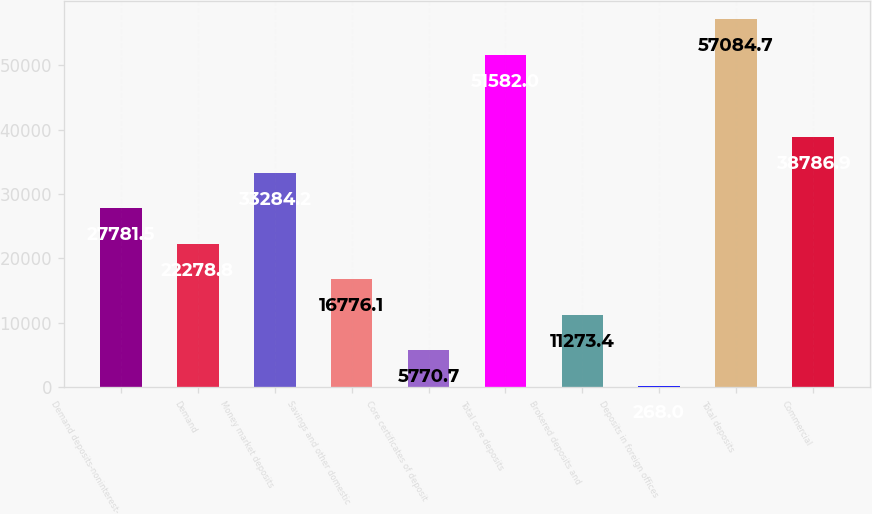Convert chart. <chart><loc_0><loc_0><loc_500><loc_500><bar_chart><fcel>Demand deposits-noninterest-<fcel>Demand<fcel>Money market deposits<fcel>Savings and other domestic<fcel>Core certificates of deposit<fcel>Total core deposits<fcel>Brokered deposits and<fcel>Deposits in foreign offices<fcel>Total deposits<fcel>Commercial<nl><fcel>27781.5<fcel>22278.8<fcel>33284.2<fcel>16776.1<fcel>5770.7<fcel>51582<fcel>11273.4<fcel>268<fcel>57084.7<fcel>38786.9<nl></chart> 